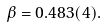<formula> <loc_0><loc_0><loc_500><loc_500>\beta = 0 . 4 8 3 ( 4 ) .</formula> 